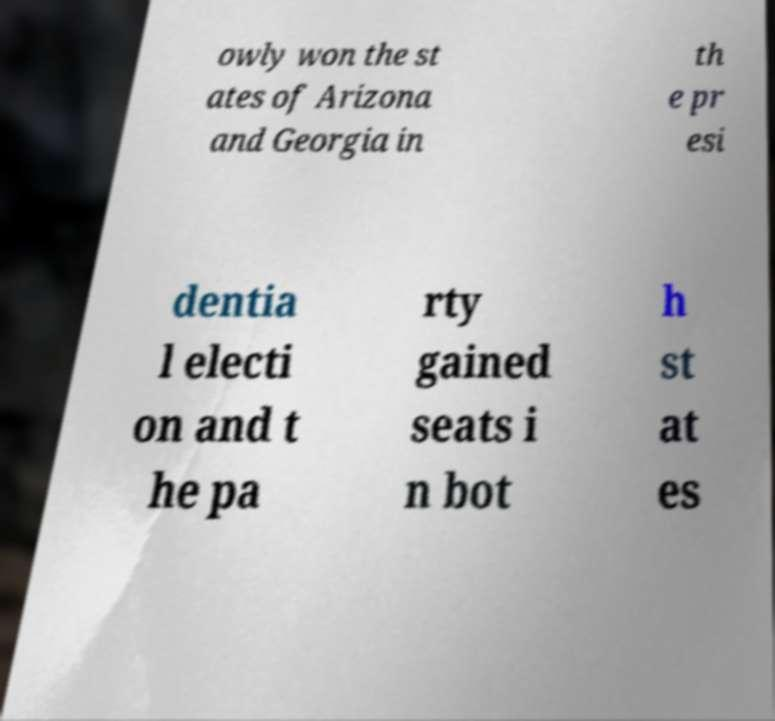Can you read and provide the text displayed in the image?This photo seems to have some interesting text. Can you extract and type it out for me? owly won the st ates of Arizona and Georgia in th e pr esi dentia l electi on and t he pa rty gained seats i n bot h st at es 